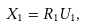<formula> <loc_0><loc_0><loc_500><loc_500>X _ { 1 } = R _ { 1 } U _ { 1 } ,</formula> 